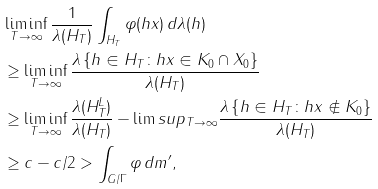Convert formula to latex. <formula><loc_0><loc_0><loc_500><loc_500>& \liminf _ { T \to \infty } \frac { 1 } { \lambda ( H _ { T } ) } \int _ { H _ { T } } \varphi ( h x ) \, d \lambda ( h ) \\ & \geq \liminf _ { T \to \infty } \frac { \lambda \left \{ h \in H _ { T } \colon h x \in K _ { 0 } \cap X _ { 0 } \right \} } { \lambda ( H _ { T } ) } \\ & \geq \liminf _ { T \to \infty } \frac { \lambda ( H _ { T } ^ { L } ) } { \lambda ( H _ { T } ) } - \lim s u p _ { T \to \infty } \frac { \lambda \left \{ h \in H _ { T } \colon h x \notin K _ { 0 } \right \} } { \lambda ( H _ { T } ) } \\ & \geq c - c / 2 > \int _ { G / \Gamma } \varphi \, d m ^ { \prime } ,</formula> 